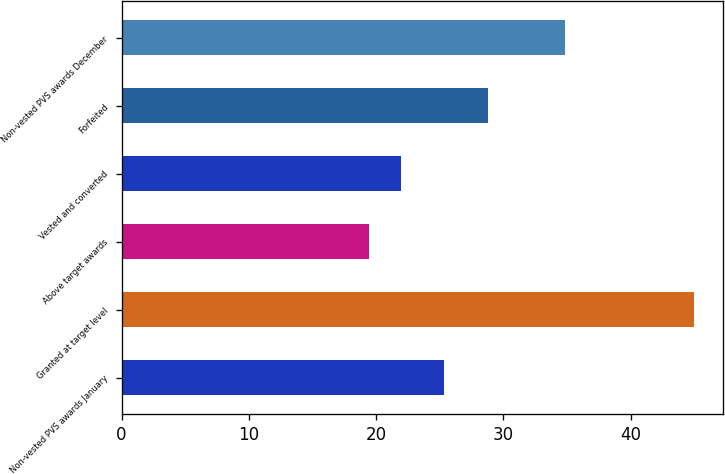Convert chart to OTSL. <chart><loc_0><loc_0><loc_500><loc_500><bar_chart><fcel>Non-vested PVS awards January<fcel>Granted at target level<fcel>Above target awards<fcel>Vested and converted<fcel>Forfeited<fcel>Non-vested PVS awards December<nl><fcel>25.35<fcel>44.96<fcel>19.41<fcel>21.96<fcel>28.79<fcel>34.81<nl></chart> 